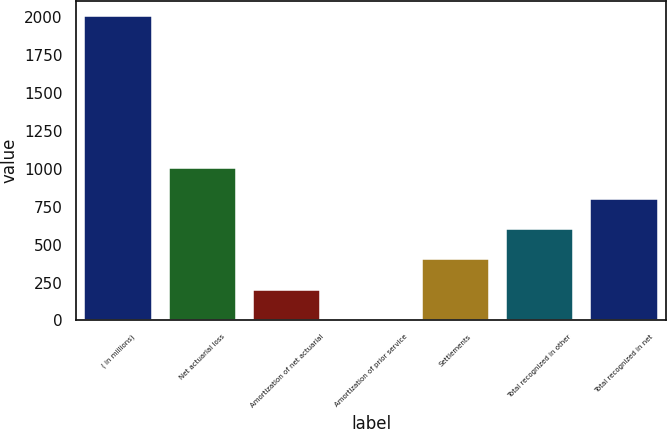Convert chart. <chart><loc_0><loc_0><loc_500><loc_500><bar_chart><fcel>( in millions)<fcel>Net actuarial loss<fcel>Amortization of net actuarial<fcel>Amortization of prior service<fcel>Settlements<fcel>Total recognized in other<fcel>Total recognized in net<nl><fcel>2008<fcel>1004.5<fcel>201.7<fcel>1<fcel>402.4<fcel>603.1<fcel>803.8<nl></chart> 